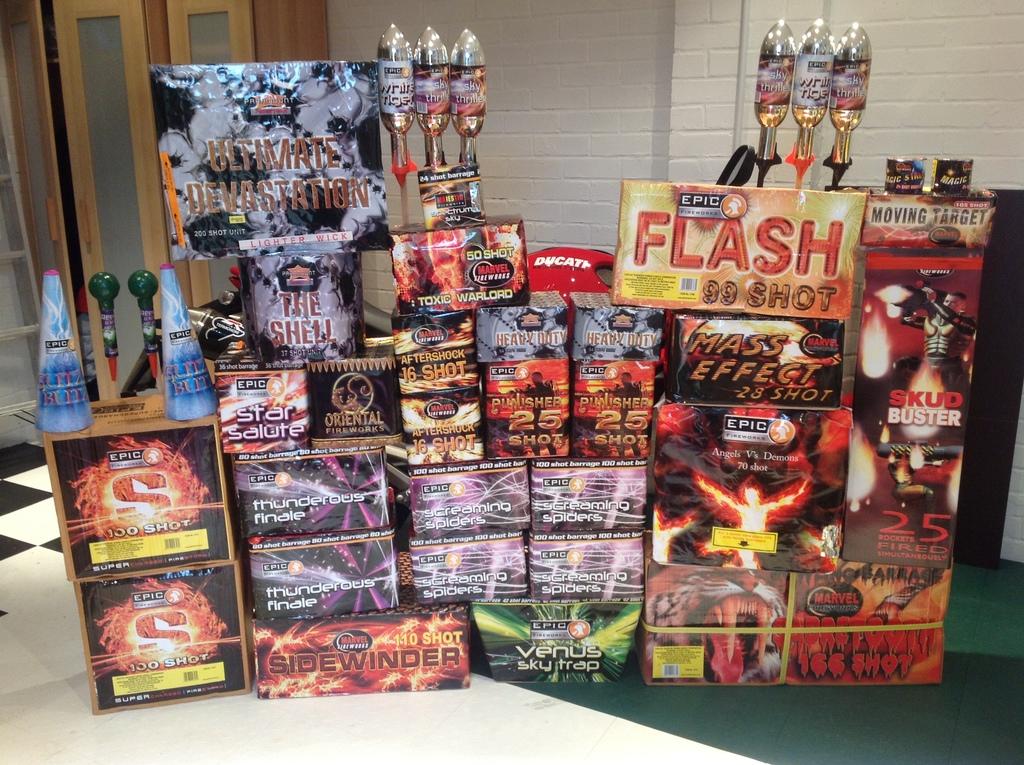How many shots are in the flash box?
Offer a terse response. 99. What are these items?
Your answer should be very brief. Fireworks. 